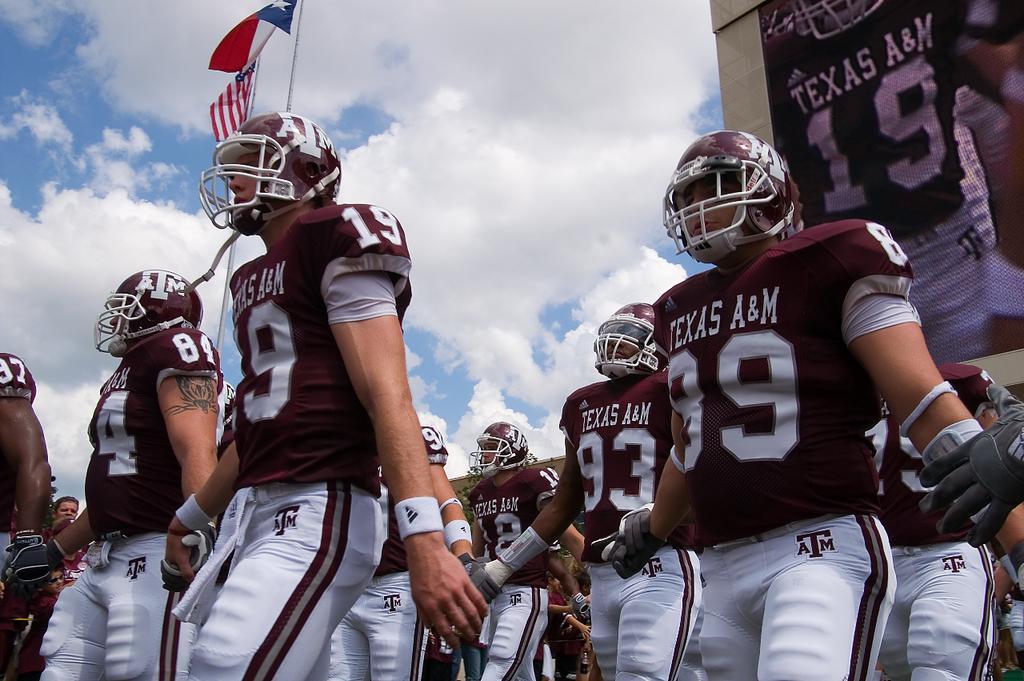How would you summarize this image in a sentence or two? In this image there are group of people with gloves and helmets are standing , and there are flags with the poles, a screen to the building or a wall , and in the background there is sky. 